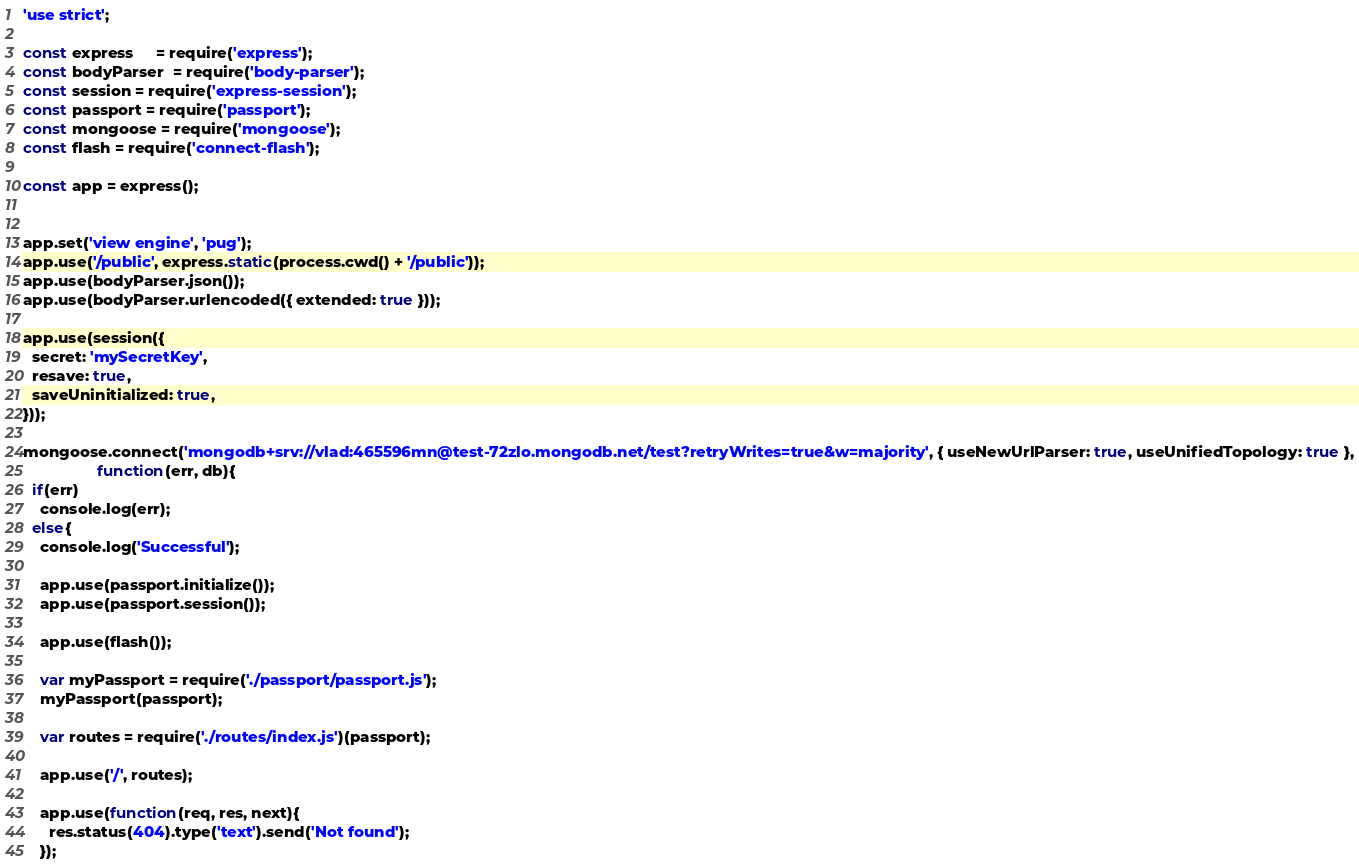Convert code to text. <code><loc_0><loc_0><loc_500><loc_500><_JavaScript_>'use strict';

const express     = require('express');
const bodyParser  = require('body-parser');
const session = require('express-session');
const passport = require('passport');
const mongoose = require('mongoose');
const flash = require('connect-flash');

const app = express();


app.set('view engine', 'pug');
app.use('/public', express.static(process.cwd() + '/public'));
app.use(bodyParser.json());
app.use(bodyParser.urlencoded({ extended: true }));

app.use(session({
  secret: 'mySecretKey',
  resave: true,
  saveUninitialized: true,
}));

mongoose.connect('mongodb+srv://vlad:465596mn@test-72zlo.mongodb.net/test?retryWrites=true&w=majority', { useNewUrlParser: true, useUnifiedTopology: true },
                 function(err, db){
  if(err) 
    console.log(err);
  else{
    console.log('Successful');
  
    app.use(passport.initialize());
    app.use(passport.session());
    
    app.use(flash());
    
    var myPassport = require('./passport/passport.js');
    myPassport(passport);
    
    var routes = require('./routes/index.js')(passport);
    
    app.use('/', routes);

    app.use(function(req, res, next){
      res.status(404).type('text').send('Not found');
    });
</code> 